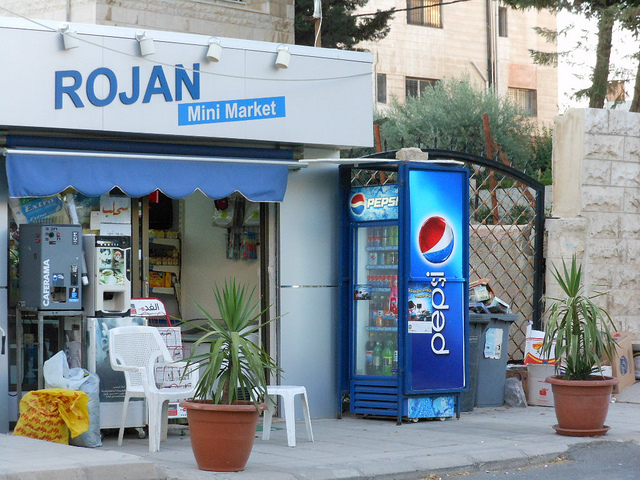How many potted plants are there? There are two potted plants visible in the image, one on each side of the Pepsi refrigerator, positioned outside what appears to be a small convenience store. 